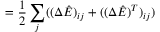Convert formula to latex. <formula><loc_0><loc_0><loc_500><loc_500>= \frac { 1 } { 2 } \sum _ { j } ( ( \Delta \hat { E } ) _ { i j } + ( ( \Delta \hat { E } ) ^ { T } ) _ { i j } )</formula> 